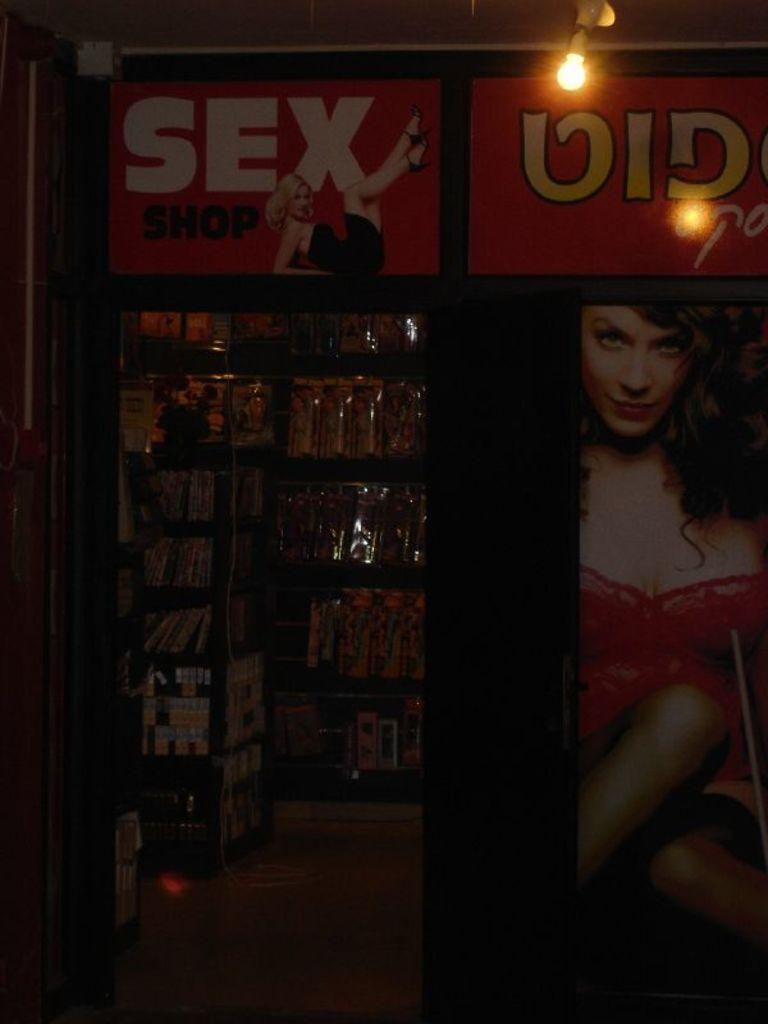What type of establishment is shown in the image? There is a store in the image. What can be seen on the banners in the image? The content of the banners is not specified, but they are present in the image. What type of illumination is visible in the image? There is light in the image. What part of the store is visible in the image? The inside view of the store is visible on the left side of the image. What can be found inside the store? There are objects inside the store. What is the surface that people walk on inside the store? There is a floor visible inside the store. What grade does the robin in the image receive for its performance? There is no robin present in the image; it is a store with banners, light, and objects inside. 